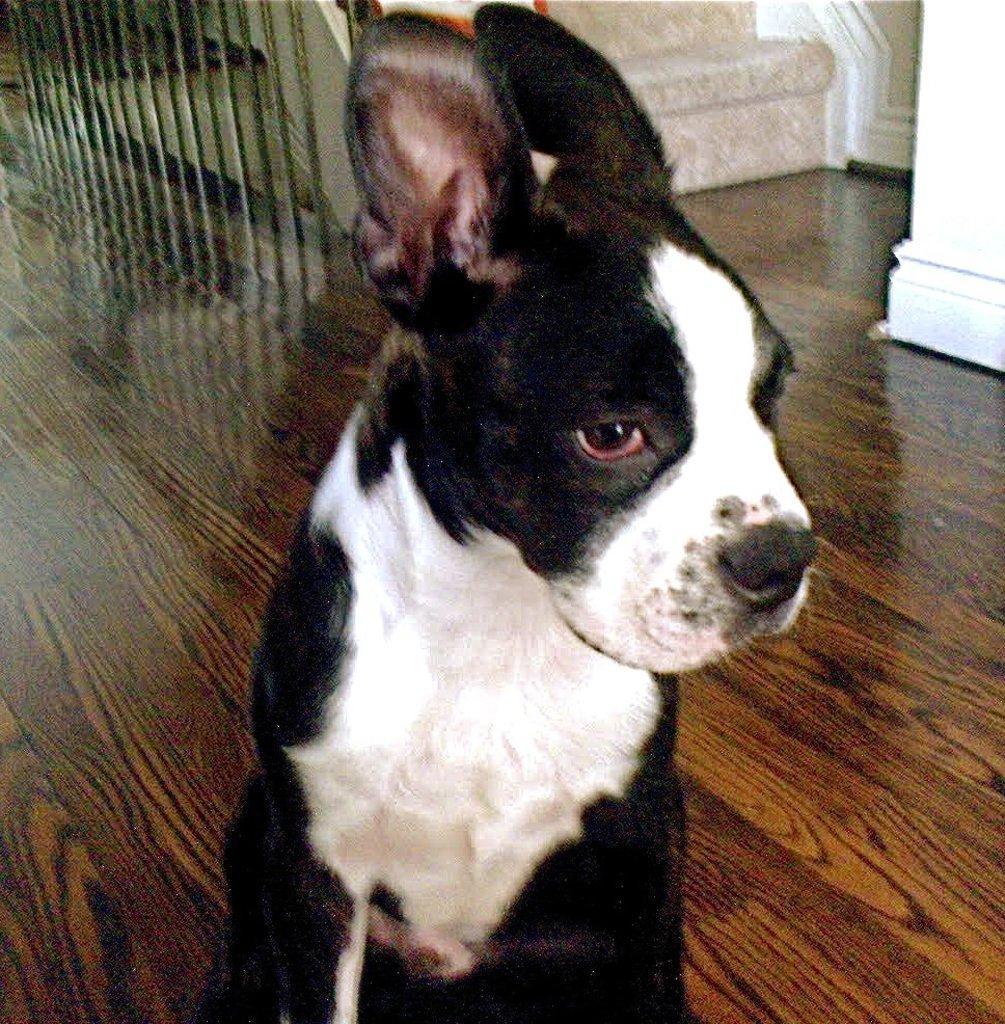How would you summarize this image in a sentence or two? In this image there is a dog on the floor. In the background there are steps. Beside the steps there is a railing. On the right side top it looks like a pillar. 